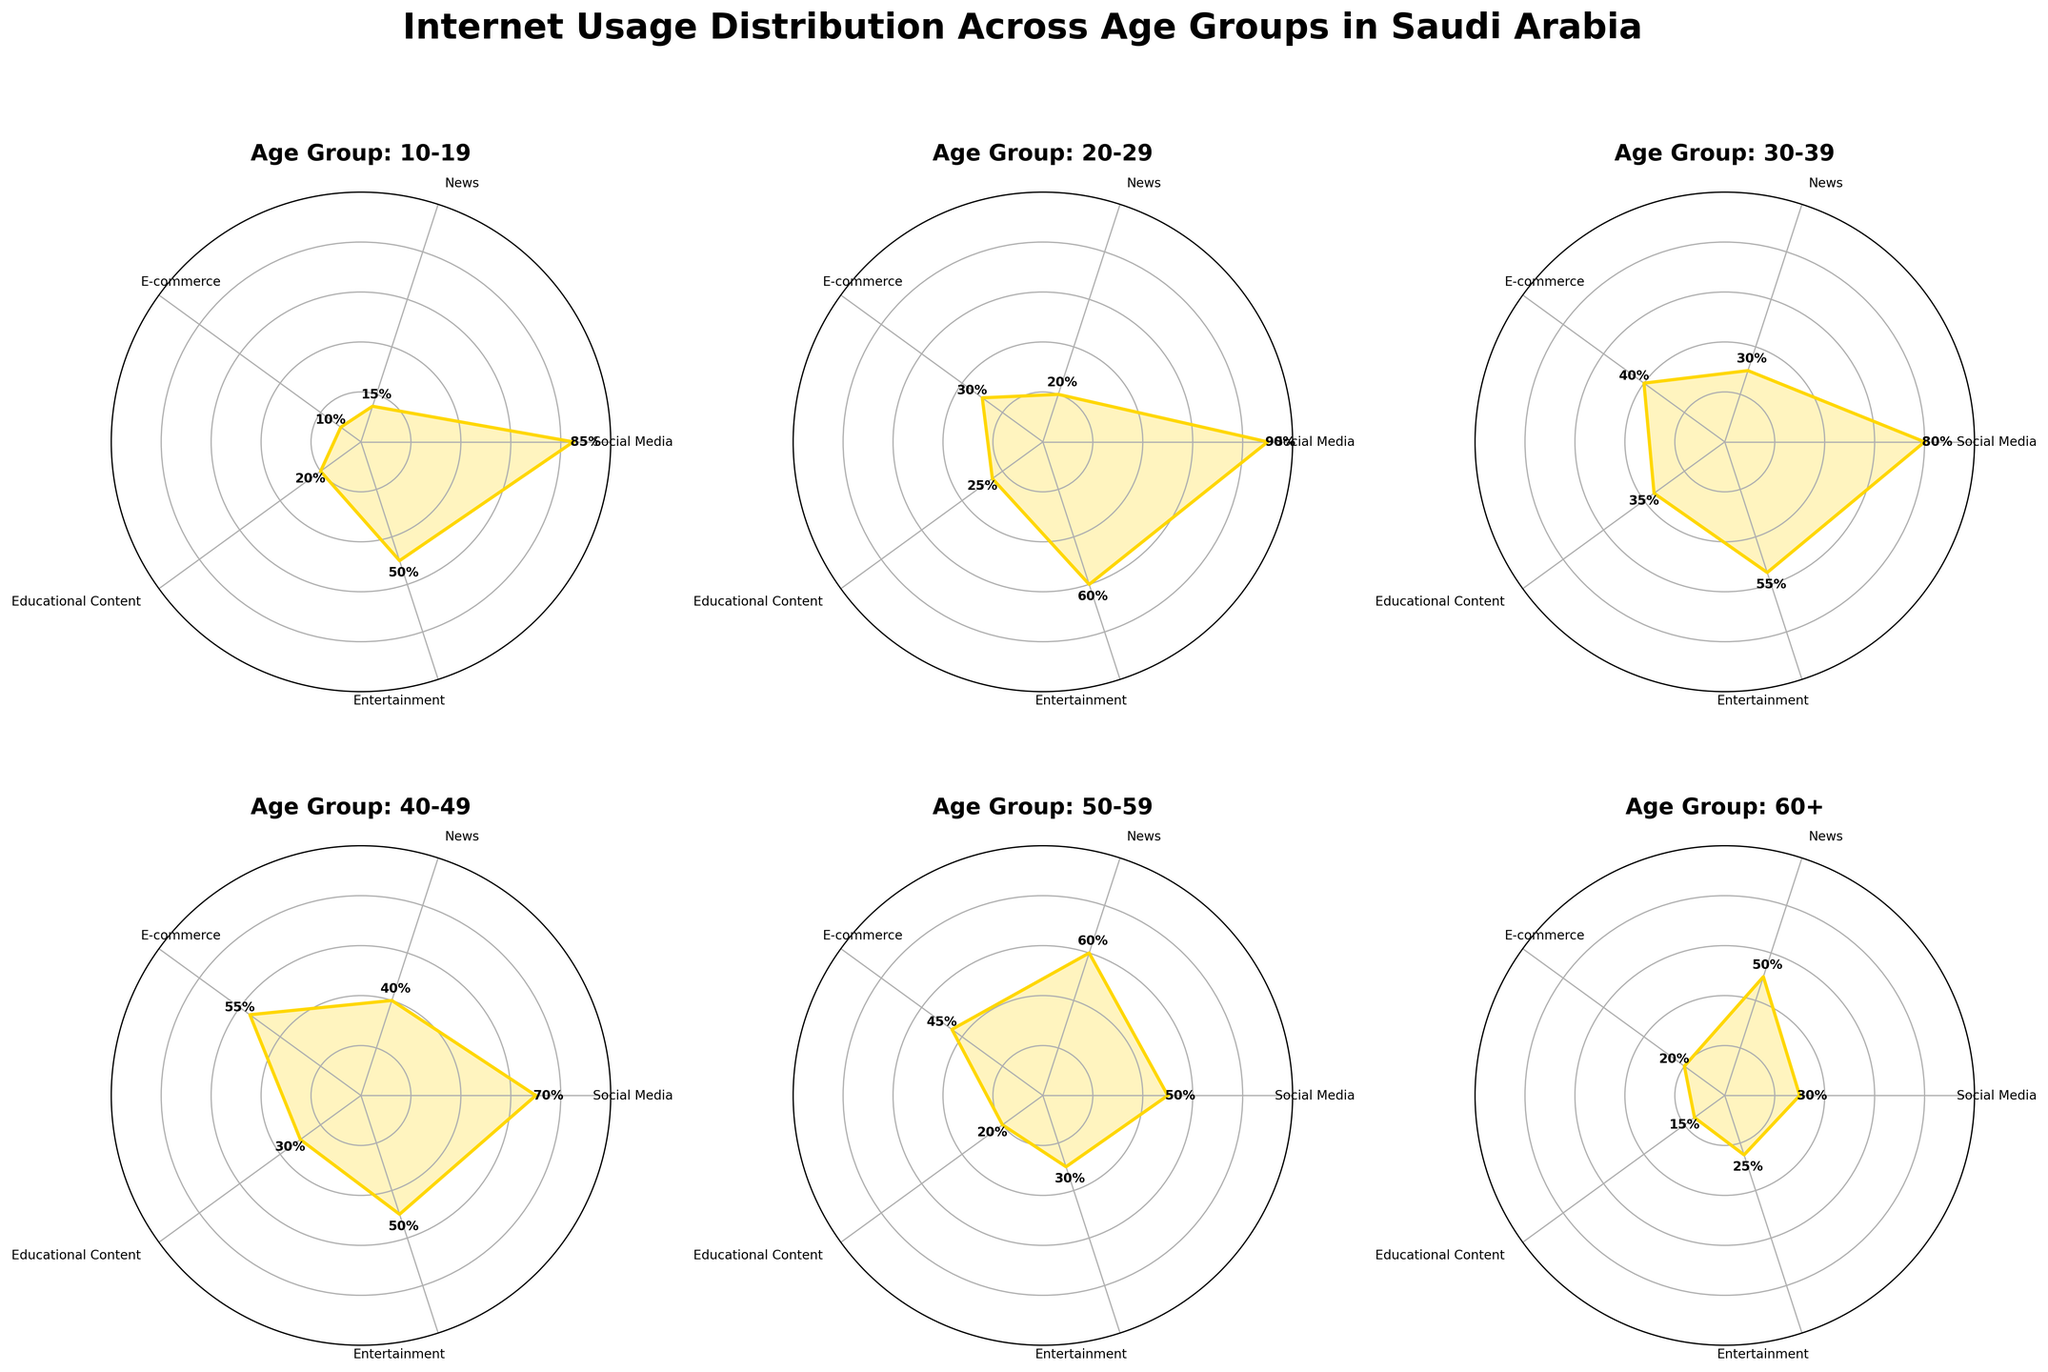What are the age groups represented in the plots? The age groups are labeled in the titles of each subplot. According to the titles, the age groups include: 10-19, 20-29, 30-39, 40-49, 50-59, and 60+.
Answer: 10-19, 20-29, 30-39, 40-49, 50-59, 60+ Which internet usage category is most used by the 20-29 age group? By looking at the radial length in the plot for the 20-29 age group, the longest section corresponds to Social Media usage.
Answer: Social Media How much more does the 40-49 age group use E-commerce compared to the 20-29 age group? The 40-49 age group has an E-commerce usage of 55% and the 20-29 age group has 30%. The difference is 55% - 30%.
Answer: 25% Which age group uses News the most? By comparing the radial lengths for News usage in each subplot, the longest radial length for News usage is in the 50-59 age group.
Answer: 50-59 Is Educational Content usage generally higher or lower among older age groups (40 and above)? Observing the subplots for the older age groups (40-49, 50-59, 60+), the values for Educational Content are 30%, 20%, and 15% respectively. This indicates a downward trend.
Answer: Lower Across all age groups, which category shows the highest usage overall? The category with consistently high radial lengths across all subplots is Social Media.
Answer: Social Media For the 60+ age group, which two internet usage categories have equal usage percentages? In the 60+ age group subplot, both News and Entertainment have the same radial length.
Answer: News, Entertainment How does Entertainment usage compare between the youngest (10-19) and oldest (60+) age groups? Referring to their respective subplots, Entertainment usage is 50% for the 10-19 group and 25% for the 60+ group. The 10-19 age group has a higher Entertainment usage.
Answer: Higher in 10-19 What is the average percentage of E-commerce usage among all age groups? Summing the E-commerce usage percentages: 10% (10-19) + 30% (20-29) + 40% (30-39) + 55% (40-49) + 45% (50-59) + 20% (60+) = 200. Dividing by the number of age groups (6) gives an average of 200 / 6.
Answer: 33.33% 